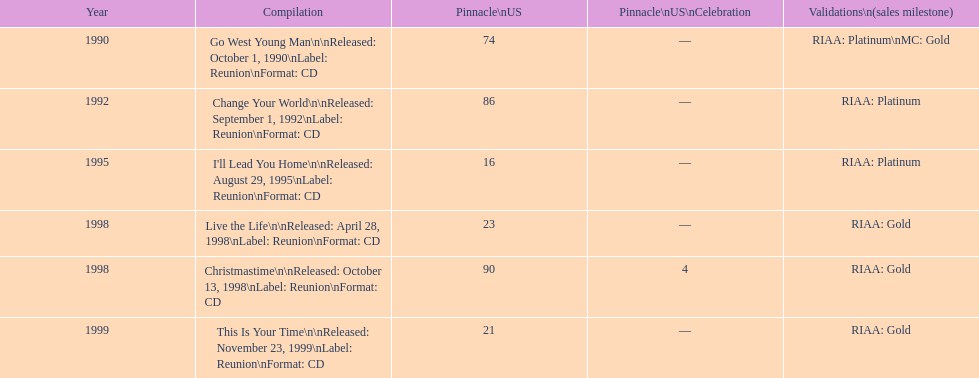What year comes after 1995? 1998. 